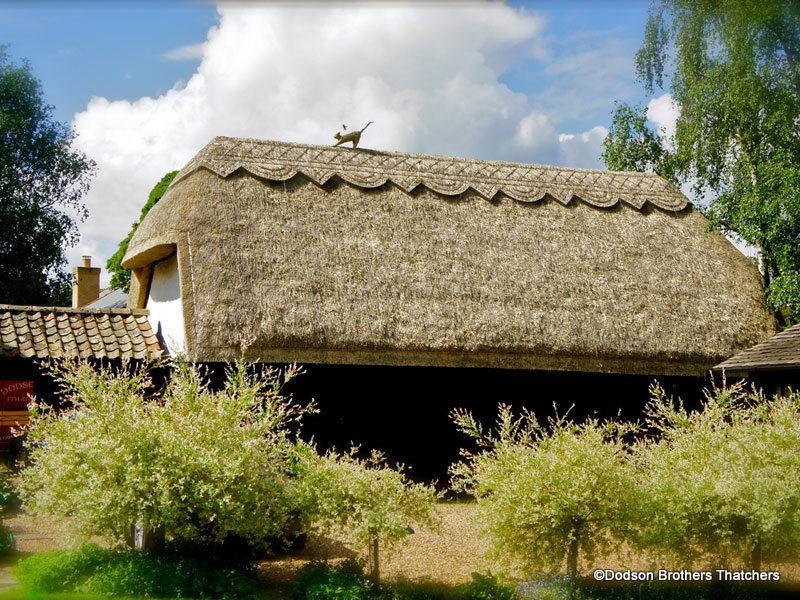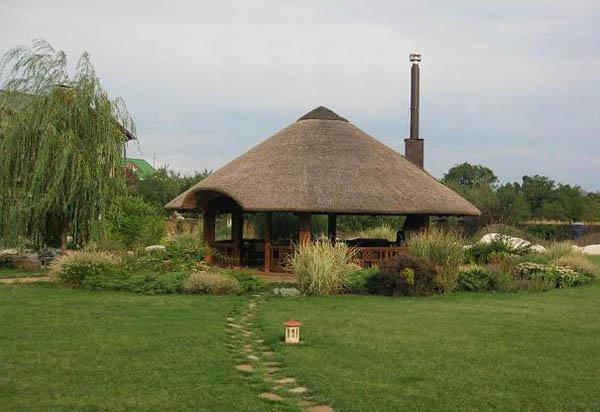The first image is the image on the left, the second image is the image on the right. Assess this claim about the two images: "The right image shows a simple square structure with a sloping shaggy thatched roof that has a flat ridge on top, sitting on a green field with no landscaping around it.". Correct or not? Answer yes or no. No. 